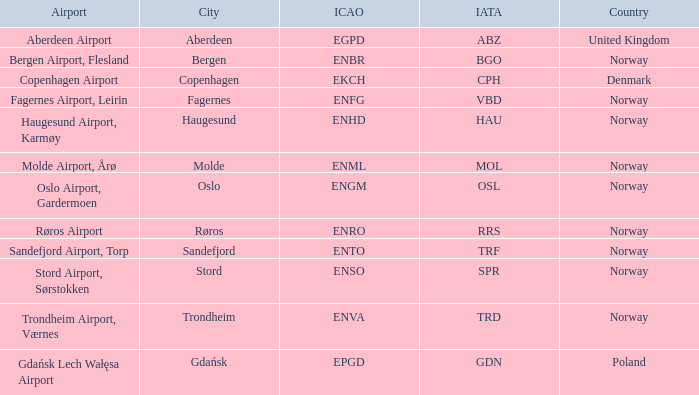What Airport's ICAO is ENTO? Sandefjord Airport, Torp. 